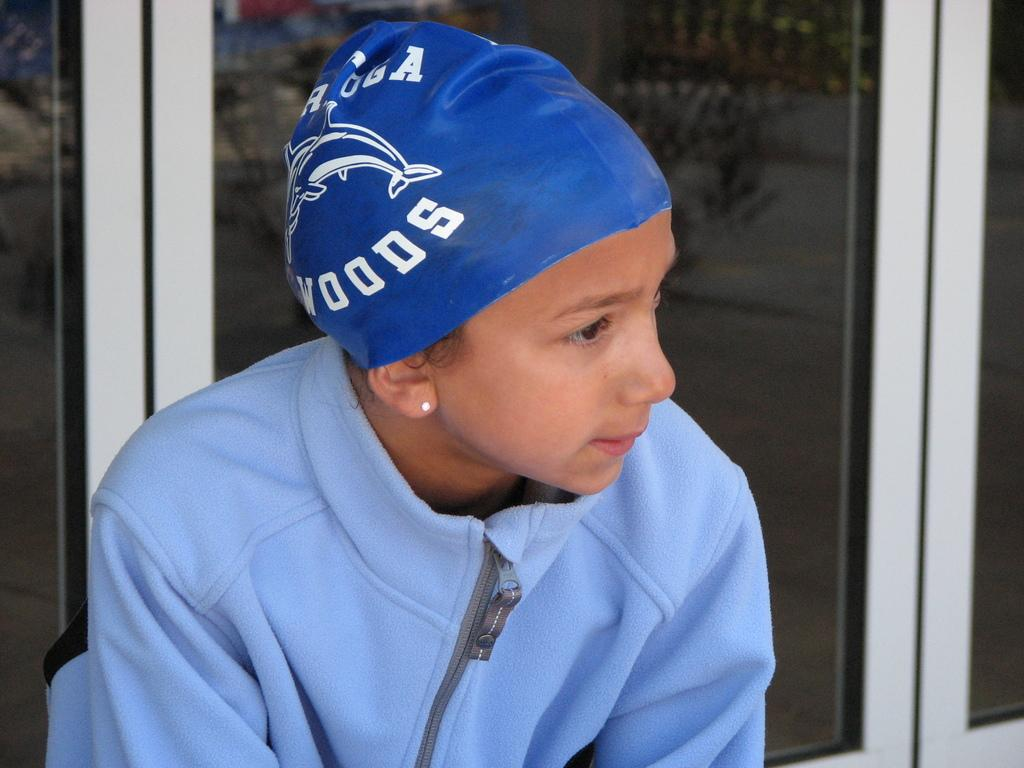Who is the main subject in the image? There is a girl in the image. What is the girl wearing? The girl is wearing a blue jacket and a blue cap. What can be seen behind the girl in the image? There are glass doors visible in the image. How many brothers does the girl have in the image? There is no information about the girl's brothers in the image. 